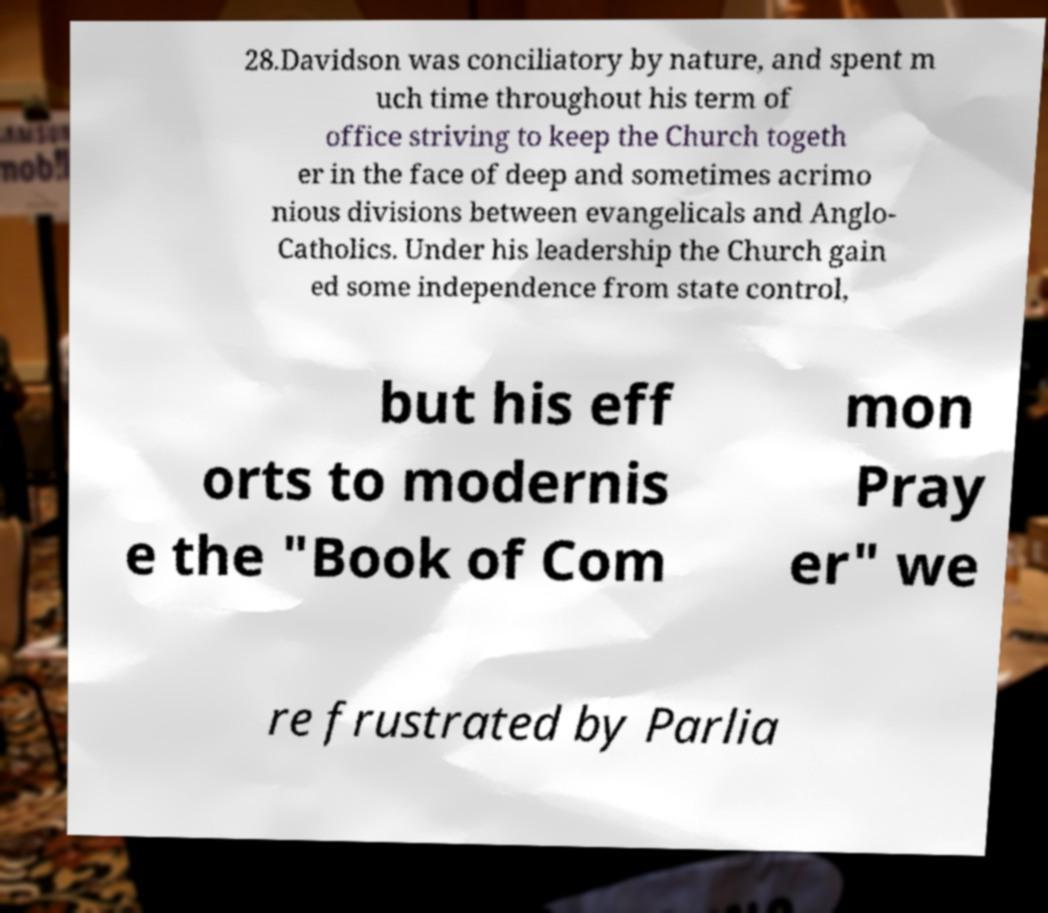Could you assist in decoding the text presented in this image and type it out clearly? 28.Davidson was conciliatory by nature, and spent m uch time throughout his term of office striving to keep the Church togeth er in the face of deep and sometimes acrimo nious divisions between evangelicals and Anglo- Catholics. Under his leadership the Church gain ed some independence from state control, but his eff orts to modernis e the "Book of Com mon Pray er" we re frustrated by Parlia 